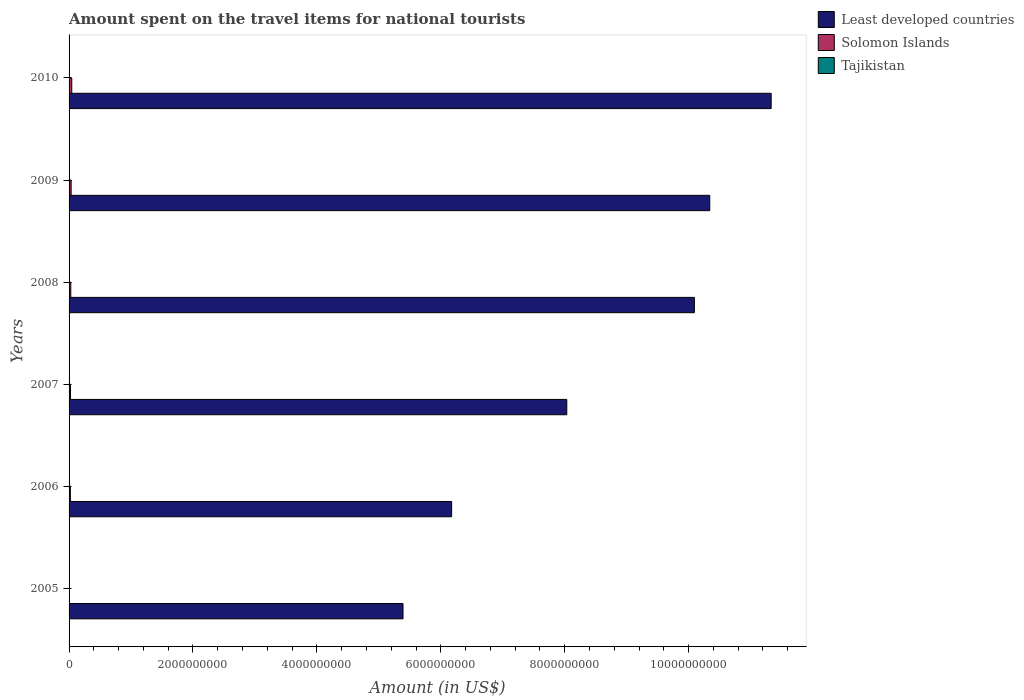How many groups of bars are there?
Ensure brevity in your answer.  6. Are the number of bars on each tick of the Y-axis equal?
Your response must be concise. Yes. What is the amount spent on the travel items for national tourists in Tajikistan in 2007?
Provide a succinct answer. 3.30e+06. Across all years, what is the maximum amount spent on the travel items for national tourists in Tajikistan?
Offer a very short reply. 4.50e+06. Across all years, what is the minimum amount spent on the travel items for national tourists in Least developed countries?
Your answer should be very brief. 5.39e+09. What is the total amount spent on the travel items for national tourists in Tajikistan in the graph?
Your answer should be compact. 1.81e+07. What is the difference between the amount spent on the travel items for national tourists in Least developed countries in 2006 and that in 2010?
Provide a succinct answer. -5.16e+09. What is the difference between the amount spent on the travel items for national tourists in Least developed countries in 2006 and the amount spent on the travel items for national tourists in Solomon Islands in 2005?
Provide a succinct answer. 6.17e+09. What is the average amount spent on the travel items for national tourists in Solomon Islands per year?
Make the answer very short. 2.50e+07. In the year 2007, what is the difference between the amount spent on the travel items for national tourists in Tajikistan and amount spent on the travel items for national tourists in Solomon Islands?
Provide a short and direct response. -1.93e+07. In how many years, is the amount spent on the travel items for national tourists in Least developed countries greater than 8000000000 US$?
Your answer should be compact. 4. What is the ratio of the amount spent on the travel items for national tourists in Solomon Islands in 2007 to that in 2008?
Your response must be concise. 0.82. What is the difference between the highest and the lowest amount spent on the travel items for national tourists in Solomon Islands?
Provide a succinct answer. 4.19e+07. In how many years, is the amount spent on the travel items for national tourists in Tajikistan greater than the average amount spent on the travel items for national tourists in Tajikistan taken over all years?
Give a very brief answer. 3. Is the sum of the amount spent on the travel items for national tourists in Solomon Islands in 2008 and 2010 greater than the maximum amount spent on the travel items for national tourists in Least developed countries across all years?
Your answer should be very brief. No. What does the 3rd bar from the top in 2009 represents?
Your response must be concise. Least developed countries. What does the 2nd bar from the bottom in 2008 represents?
Offer a terse response. Solomon Islands. Is it the case that in every year, the sum of the amount spent on the travel items for national tourists in Solomon Islands and amount spent on the travel items for national tourists in Least developed countries is greater than the amount spent on the travel items for national tourists in Tajikistan?
Your answer should be compact. Yes. How many bars are there?
Keep it short and to the point. 18. Are all the bars in the graph horizontal?
Offer a very short reply. Yes. Are the values on the major ticks of X-axis written in scientific E-notation?
Provide a succinct answer. No. Does the graph contain grids?
Your answer should be compact. No. Where does the legend appear in the graph?
Your answer should be very brief. Top right. How are the legend labels stacked?
Provide a succinct answer. Vertical. What is the title of the graph?
Keep it short and to the point. Amount spent on the travel items for national tourists. What is the label or title of the X-axis?
Keep it short and to the point. Amount (in US$). What is the label or title of the Y-axis?
Provide a short and direct response. Years. What is the Amount (in US$) in Least developed countries in 2005?
Make the answer very short. 5.39e+09. What is the Amount (in US$) of Solomon Islands in 2005?
Provide a short and direct response. 1.60e+06. What is the Amount (in US$) of Tajikistan in 2005?
Your answer should be very brief. 1.60e+06. What is the Amount (in US$) in Least developed countries in 2006?
Ensure brevity in your answer.  6.17e+09. What is the Amount (in US$) in Solomon Islands in 2006?
Make the answer very short. 2.11e+07. What is the Amount (in US$) of Tajikistan in 2006?
Provide a succinct answer. 2.10e+06. What is the Amount (in US$) of Least developed countries in 2007?
Make the answer very short. 8.03e+09. What is the Amount (in US$) of Solomon Islands in 2007?
Ensure brevity in your answer.  2.26e+07. What is the Amount (in US$) in Tajikistan in 2007?
Ensure brevity in your answer.  3.30e+06. What is the Amount (in US$) of Least developed countries in 2008?
Your answer should be very brief. 1.01e+1. What is the Amount (in US$) in Solomon Islands in 2008?
Offer a terse response. 2.75e+07. What is the Amount (in US$) in Tajikistan in 2008?
Keep it short and to the point. 4.20e+06. What is the Amount (in US$) of Least developed countries in 2009?
Give a very brief answer. 1.03e+1. What is the Amount (in US$) in Solomon Islands in 2009?
Provide a succinct answer. 3.34e+07. What is the Amount (in US$) of Tajikistan in 2009?
Your response must be concise. 2.40e+06. What is the Amount (in US$) in Least developed countries in 2010?
Your response must be concise. 1.13e+1. What is the Amount (in US$) of Solomon Islands in 2010?
Offer a terse response. 4.35e+07. What is the Amount (in US$) of Tajikistan in 2010?
Make the answer very short. 4.50e+06. Across all years, what is the maximum Amount (in US$) of Least developed countries?
Make the answer very short. 1.13e+1. Across all years, what is the maximum Amount (in US$) in Solomon Islands?
Give a very brief answer. 4.35e+07. Across all years, what is the maximum Amount (in US$) of Tajikistan?
Keep it short and to the point. 4.50e+06. Across all years, what is the minimum Amount (in US$) in Least developed countries?
Offer a terse response. 5.39e+09. Across all years, what is the minimum Amount (in US$) of Solomon Islands?
Offer a very short reply. 1.60e+06. Across all years, what is the minimum Amount (in US$) of Tajikistan?
Keep it short and to the point. 1.60e+06. What is the total Amount (in US$) in Least developed countries in the graph?
Your answer should be very brief. 5.14e+1. What is the total Amount (in US$) in Solomon Islands in the graph?
Ensure brevity in your answer.  1.50e+08. What is the total Amount (in US$) in Tajikistan in the graph?
Your answer should be very brief. 1.81e+07. What is the difference between the Amount (in US$) of Least developed countries in 2005 and that in 2006?
Offer a terse response. -7.85e+08. What is the difference between the Amount (in US$) of Solomon Islands in 2005 and that in 2006?
Offer a terse response. -1.95e+07. What is the difference between the Amount (in US$) of Tajikistan in 2005 and that in 2006?
Your answer should be compact. -5.00e+05. What is the difference between the Amount (in US$) of Least developed countries in 2005 and that in 2007?
Offer a terse response. -2.64e+09. What is the difference between the Amount (in US$) of Solomon Islands in 2005 and that in 2007?
Offer a very short reply. -2.10e+07. What is the difference between the Amount (in US$) of Tajikistan in 2005 and that in 2007?
Your answer should be very brief. -1.70e+06. What is the difference between the Amount (in US$) of Least developed countries in 2005 and that in 2008?
Your answer should be compact. -4.70e+09. What is the difference between the Amount (in US$) in Solomon Islands in 2005 and that in 2008?
Provide a short and direct response. -2.59e+07. What is the difference between the Amount (in US$) in Tajikistan in 2005 and that in 2008?
Ensure brevity in your answer.  -2.60e+06. What is the difference between the Amount (in US$) in Least developed countries in 2005 and that in 2009?
Offer a very short reply. -4.95e+09. What is the difference between the Amount (in US$) of Solomon Islands in 2005 and that in 2009?
Offer a very short reply. -3.18e+07. What is the difference between the Amount (in US$) of Tajikistan in 2005 and that in 2009?
Offer a very short reply. -8.00e+05. What is the difference between the Amount (in US$) in Least developed countries in 2005 and that in 2010?
Your answer should be very brief. -5.94e+09. What is the difference between the Amount (in US$) of Solomon Islands in 2005 and that in 2010?
Provide a short and direct response. -4.19e+07. What is the difference between the Amount (in US$) of Tajikistan in 2005 and that in 2010?
Give a very brief answer. -2.90e+06. What is the difference between the Amount (in US$) of Least developed countries in 2006 and that in 2007?
Your answer should be compact. -1.86e+09. What is the difference between the Amount (in US$) of Solomon Islands in 2006 and that in 2007?
Offer a terse response. -1.50e+06. What is the difference between the Amount (in US$) of Tajikistan in 2006 and that in 2007?
Ensure brevity in your answer.  -1.20e+06. What is the difference between the Amount (in US$) in Least developed countries in 2006 and that in 2008?
Offer a very short reply. -3.92e+09. What is the difference between the Amount (in US$) in Solomon Islands in 2006 and that in 2008?
Your answer should be compact. -6.40e+06. What is the difference between the Amount (in US$) in Tajikistan in 2006 and that in 2008?
Make the answer very short. -2.10e+06. What is the difference between the Amount (in US$) in Least developed countries in 2006 and that in 2009?
Your answer should be compact. -4.17e+09. What is the difference between the Amount (in US$) in Solomon Islands in 2006 and that in 2009?
Your answer should be compact. -1.23e+07. What is the difference between the Amount (in US$) in Tajikistan in 2006 and that in 2009?
Your answer should be very brief. -3.00e+05. What is the difference between the Amount (in US$) of Least developed countries in 2006 and that in 2010?
Make the answer very short. -5.16e+09. What is the difference between the Amount (in US$) of Solomon Islands in 2006 and that in 2010?
Offer a very short reply. -2.24e+07. What is the difference between the Amount (in US$) in Tajikistan in 2006 and that in 2010?
Offer a terse response. -2.40e+06. What is the difference between the Amount (in US$) in Least developed countries in 2007 and that in 2008?
Your response must be concise. -2.06e+09. What is the difference between the Amount (in US$) in Solomon Islands in 2007 and that in 2008?
Your answer should be compact. -4.90e+06. What is the difference between the Amount (in US$) of Tajikistan in 2007 and that in 2008?
Provide a short and direct response. -9.00e+05. What is the difference between the Amount (in US$) of Least developed countries in 2007 and that in 2009?
Offer a terse response. -2.31e+09. What is the difference between the Amount (in US$) of Solomon Islands in 2007 and that in 2009?
Your response must be concise. -1.08e+07. What is the difference between the Amount (in US$) of Least developed countries in 2007 and that in 2010?
Ensure brevity in your answer.  -3.30e+09. What is the difference between the Amount (in US$) of Solomon Islands in 2007 and that in 2010?
Keep it short and to the point. -2.09e+07. What is the difference between the Amount (in US$) in Tajikistan in 2007 and that in 2010?
Your answer should be compact. -1.20e+06. What is the difference between the Amount (in US$) in Least developed countries in 2008 and that in 2009?
Your answer should be compact. -2.48e+08. What is the difference between the Amount (in US$) of Solomon Islands in 2008 and that in 2009?
Offer a terse response. -5.90e+06. What is the difference between the Amount (in US$) in Tajikistan in 2008 and that in 2009?
Provide a succinct answer. 1.80e+06. What is the difference between the Amount (in US$) in Least developed countries in 2008 and that in 2010?
Ensure brevity in your answer.  -1.24e+09. What is the difference between the Amount (in US$) of Solomon Islands in 2008 and that in 2010?
Ensure brevity in your answer.  -1.60e+07. What is the difference between the Amount (in US$) in Least developed countries in 2009 and that in 2010?
Ensure brevity in your answer.  -9.91e+08. What is the difference between the Amount (in US$) in Solomon Islands in 2009 and that in 2010?
Your answer should be very brief. -1.01e+07. What is the difference between the Amount (in US$) in Tajikistan in 2009 and that in 2010?
Keep it short and to the point. -2.10e+06. What is the difference between the Amount (in US$) of Least developed countries in 2005 and the Amount (in US$) of Solomon Islands in 2006?
Your response must be concise. 5.37e+09. What is the difference between the Amount (in US$) in Least developed countries in 2005 and the Amount (in US$) in Tajikistan in 2006?
Your answer should be very brief. 5.39e+09. What is the difference between the Amount (in US$) in Solomon Islands in 2005 and the Amount (in US$) in Tajikistan in 2006?
Provide a succinct answer. -5.00e+05. What is the difference between the Amount (in US$) in Least developed countries in 2005 and the Amount (in US$) in Solomon Islands in 2007?
Offer a very short reply. 5.37e+09. What is the difference between the Amount (in US$) in Least developed countries in 2005 and the Amount (in US$) in Tajikistan in 2007?
Ensure brevity in your answer.  5.39e+09. What is the difference between the Amount (in US$) of Solomon Islands in 2005 and the Amount (in US$) of Tajikistan in 2007?
Offer a very short reply. -1.70e+06. What is the difference between the Amount (in US$) of Least developed countries in 2005 and the Amount (in US$) of Solomon Islands in 2008?
Provide a short and direct response. 5.36e+09. What is the difference between the Amount (in US$) of Least developed countries in 2005 and the Amount (in US$) of Tajikistan in 2008?
Give a very brief answer. 5.39e+09. What is the difference between the Amount (in US$) of Solomon Islands in 2005 and the Amount (in US$) of Tajikistan in 2008?
Give a very brief answer. -2.60e+06. What is the difference between the Amount (in US$) of Least developed countries in 2005 and the Amount (in US$) of Solomon Islands in 2009?
Give a very brief answer. 5.36e+09. What is the difference between the Amount (in US$) in Least developed countries in 2005 and the Amount (in US$) in Tajikistan in 2009?
Your answer should be compact. 5.39e+09. What is the difference between the Amount (in US$) in Solomon Islands in 2005 and the Amount (in US$) in Tajikistan in 2009?
Make the answer very short. -8.00e+05. What is the difference between the Amount (in US$) in Least developed countries in 2005 and the Amount (in US$) in Solomon Islands in 2010?
Make the answer very short. 5.35e+09. What is the difference between the Amount (in US$) in Least developed countries in 2005 and the Amount (in US$) in Tajikistan in 2010?
Your answer should be very brief. 5.39e+09. What is the difference between the Amount (in US$) of Solomon Islands in 2005 and the Amount (in US$) of Tajikistan in 2010?
Provide a short and direct response. -2.90e+06. What is the difference between the Amount (in US$) in Least developed countries in 2006 and the Amount (in US$) in Solomon Islands in 2007?
Your answer should be very brief. 6.15e+09. What is the difference between the Amount (in US$) of Least developed countries in 2006 and the Amount (in US$) of Tajikistan in 2007?
Provide a short and direct response. 6.17e+09. What is the difference between the Amount (in US$) in Solomon Islands in 2006 and the Amount (in US$) in Tajikistan in 2007?
Provide a short and direct response. 1.78e+07. What is the difference between the Amount (in US$) in Least developed countries in 2006 and the Amount (in US$) in Solomon Islands in 2008?
Give a very brief answer. 6.15e+09. What is the difference between the Amount (in US$) in Least developed countries in 2006 and the Amount (in US$) in Tajikistan in 2008?
Offer a very short reply. 6.17e+09. What is the difference between the Amount (in US$) of Solomon Islands in 2006 and the Amount (in US$) of Tajikistan in 2008?
Ensure brevity in your answer.  1.69e+07. What is the difference between the Amount (in US$) of Least developed countries in 2006 and the Amount (in US$) of Solomon Islands in 2009?
Ensure brevity in your answer.  6.14e+09. What is the difference between the Amount (in US$) in Least developed countries in 2006 and the Amount (in US$) in Tajikistan in 2009?
Your answer should be compact. 6.17e+09. What is the difference between the Amount (in US$) in Solomon Islands in 2006 and the Amount (in US$) in Tajikistan in 2009?
Make the answer very short. 1.87e+07. What is the difference between the Amount (in US$) of Least developed countries in 2006 and the Amount (in US$) of Solomon Islands in 2010?
Give a very brief answer. 6.13e+09. What is the difference between the Amount (in US$) in Least developed countries in 2006 and the Amount (in US$) in Tajikistan in 2010?
Your answer should be compact. 6.17e+09. What is the difference between the Amount (in US$) in Solomon Islands in 2006 and the Amount (in US$) in Tajikistan in 2010?
Give a very brief answer. 1.66e+07. What is the difference between the Amount (in US$) of Least developed countries in 2007 and the Amount (in US$) of Solomon Islands in 2008?
Your response must be concise. 8.01e+09. What is the difference between the Amount (in US$) in Least developed countries in 2007 and the Amount (in US$) in Tajikistan in 2008?
Make the answer very short. 8.03e+09. What is the difference between the Amount (in US$) in Solomon Islands in 2007 and the Amount (in US$) in Tajikistan in 2008?
Your response must be concise. 1.84e+07. What is the difference between the Amount (in US$) of Least developed countries in 2007 and the Amount (in US$) of Solomon Islands in 2009?
Provide a succinct answer. 8.00e+09. What is the difference between the Amount (in US$) in Least developed countries in 2007 and the Amount (in US$) in Tajikistan in 2009?
Offer a terse response. 8.03e+09. What is the difference between the Amount (in US$) in Solomon Islands in 2007 and the Amount (in US$) in Tajikistan in 2009?
Offer a terse response. 2.02e+07. What is the difference between the Amount (in US$) of Least developed countries in 2007 and the Amount (in US$) of Solomon Islands in 2010?
Ensure brevity in your answer.  7.99e+09. What is the difference between the Amount (in US$) in Least developed countries in 2007 and the Amount (in US$) in Tajikistan in 2010?
Make the answer very short. 8.03e+09. What is the difference between the Amount (in US$) in Solomon Islands in 2007 and the Amount (in US$) in Tajikistan in 2010?
Give a very brief answer. 1.81e+07. What is the difference between the Amount (in US$) in Least developed countries in 2008 and the Amount (in US$) in Solomon Islands in 2009?
Keep it short and to the point. 1.01e+1. What is the difference between the Amount (in US$) of Least developed countries in 2008 and the Amount (in US$) of Tajikistan in 2009?
Give a very brief answer. 1.01e+1. What is the difference between the Amount (in US$) of Solomon Islands in 2008 and the Amount (in US$) of Tajikistan in 2009?
Give a very brief answer. 2.51e+07. What is the difference between the Amount (in US$) in Least developed countries in 2008 and the Amount (in US$) in Solomon Islands in 2010?
Offer a very short reply. 1.00e+1. What is the difference between the Amount (in US$) in Least developed countries in 2008 and the Amount (in US$) in Tajikistan in 2010?
Your answer should be compact. 1.01e+1. What is the difference between the Amount (in US$) in Solomon Islands in 2008 and the Amount (in US$) in Tajikistan in 2010?
Provide a short and direct response. 2.30e+07. What is the difference between the Amount (in US$) of Least developed countries in 2009 and the Amount (in US$) of Solomon Islands in 2010?
Ensure brevity in your answer.  1.03e+1. What is the difference between the Amount (in US$) in Least developed countries in 2009 and the Amount (in US$) in Tajikistan in 2010?
Your answer should be very brief. 1.03e+1. What is the difference between the Amount (in US$) in Solomon Islands in 2009 and the Amount (in US$) in Tajikistan in 2010?
Your response must be concise. 2.89e+07. What is the average Amount (in US$) of Least developed countries per year?
Offer a terse response. 8.56e+09. What is the average Amount (in US$) of Solomon Islands per year?
Your response must be concise. 2.50e+07. What is the average Amount (in US$) of Tajikistan per year?
Ensure brevity in your answer.  3.02e+06. In the year 2005, what is the difference between the Amount (in US$) of Least developed countries and Amount (in US$) of Solomon Islands?
Give a very brief answer. 5.39e+09. In the year 2005, what is the difference between the Amount (in US$) in Least developed countries and Amount (in US$) in Tajikistan?
Make the answer very short. 5.39e+09. In the year 2005, what is the difference between the Amount (in US$) in Solomon Islands and Amount (in US$) in Tajikistan?
Provide a succinct answer. 0. In the year 2006, what is the difference between the Amount (in US$) of Least developed countries and Amount (in US$) of Solomon Islands?
Give a very brief answer. 6.15e+09. In the year 2006, what is the difference between the Amount (in US$) of Least developed countries and Amount (in US$) of Tajikistan?
Offer a terse response. 6.17e+09. In the year 2006, what is the difference between the Amount (in US$) in Solomon Islands and Amount (in US$) in Tajikistan?
Offer a terse response. 1.90e+07. In the year 2007, what is the difference between the Amount (in US$) in Least developed countries and Amount (in US$) in Solomon Islands?
Give a very brief answer. 8.01e+09. In the year 2007, what is the difference between the Amount (in US$) of Least developed countries and Amount (in US$) of Tajikistan?
Provide a short and direct response. 8.03e+09. In the year 2007, what is the difference between the Amount (in US$) in Solomon Islands and Amount (in US$) in Tajikistan?
Make the answer very short. 1.93e+07. In the year 2008, what is the difference between the Amount (in US$) in Least developed countries and Amount (in US$) in Solomon Islands?
Give a very brief answer. 1.01e+1. In the year 2008, what is the difference between the Amount (in US$) of Least developed countries and Amount (in US$) of Tajikistan?
Your response must be concise. 1.01e+1. In the year 2008, what is the difference between the Amount (in US$) in Solomon Islands and Amount (in US$) in Tajikistan?
Offer a terse response. 2.33e+07. In the year 2009, what is the difference between the Amount (in US$) of Least developed countries and Amount (in US$) of Solomon Islands?
Your response must be concise. 1.03e+1. In the year 2009, what is the difference between the Amount (in US$) in Least developed countries and Amount (in US$) in Tajikistan?
Your answer should be compact. 1.03e+1. In the year 2009, what is the difference between the Amount (in US$) of Solomon Islands and Amount (in US$) of Tajikistan?
Keep it short and to the point. 3.10e+07. In the year 2010, what is the difference between the Amount (in US$) of Least developed countries and Amount (in US$) of Solomon Islands?
Give a very brief answer. 1.13e+1. In the year 2010, what is the difference between the Amount (in US$) in Least developed countries and Amount (in US$) in Tajikistan?
Your response must be concise. 1.13e+1. In the year 2010, what is the difference between the Amount (in US$) in Solomon Islands and Amount (in US$) in Tajikistan?
Give a very brief answer. 3.90e+07. What is the ratio of the Amount (in US$) of Least developed countries in 2005 to that in 2006?
Offer a very short reply. 0.87. What is the ratio of the Amount (in US$) in Solomon Islands in 2005 to that in 2006?
Keep it short and to the point. 0.08. What is the ratio of the Amount (in US$) of Tajikistan in 2005 to that in 2006?
Give a very brief answer. 0.76. What is the ratio of the Amount (in US$) of Least developed countries in 2005 to that in 2007?
Give a very brief answer. 0.67. What is the ratio of the Amount (in US$) of Solomon Islands in 2005 to that in 2007?
Make the answer very short. 0.07. What is the ratio of the Amount (in US$) in Tajikistan in 2005 to that in 2007?
Your answer should be compact. 0.48. What is the ratio of the Amount (in US$) in Least developed countries in 2005 to that in 2008?
Provide a short and direct response. 0.53. What is the ratio of the Amount (in US$) of Solomon Islands in 2005 to that in 2008?
Ensure brevity in your answer.  0.06. What is the ratio of the Amount (in US$) in Tajikistan in 2005 to that in 2008?
Your answer should be very brief. 0.38. What is the ratio of the Amount (in US$) in Least developed countries in 2005 to that in 2009?
Keep it short and to the point. 0.52. What is the ratio of the Amount (in US$) of Solomon Islands in 2005 to that in 2009?
Make the answer very short. 0.05. What is the ratio of the Amount (in US$) of Least developed countries in 2005 to that in 2010?
Provide a short and direct response. 0.48. What is the ratio of the Amount (in US$) of Solomon Islands in 2005 to that in 2010?
Your answer should be very brief. 0.04. What is the ratio of the Amount (in US$) in Tajikistan in 2005 to that in 2010?
Make the answer very short. 0.36. What is the ratio of the Amount (in US$) in Least developed countries in 2006 to that in 2007?
Your response must be concise. 0.77. What is the ratio of the Amount (in US$) of Solomon Islands in 2006 to that in 2007?
Provide a short and direct response. 0.93. What is the ratio of the Amount (in US$) in Tajikistan in 2006 to that in 2007?
Offer a terse response. 0.64. What is the ratio of the Amount (in US$) of Least developed countries in 2006 to that in 2008?
Ensure brevity in your answer.  0.61. What is the ratio of the Amount (in US$) of Solomon Islands in 2006 to that in 2008?
Your answer should be very brief. 0.77. What is the ratio of the Amount (in US$) in Least developed countries in 2006 to that in 2009?
Give a very brief answer. 0.6. What is the ratio of the Amount (in US$) in Solomon Islands in 2006 to that in 2009?
Your answer should be compact. 0.63. What is the ratio of the Amount (in US$) in Tajikistan in 2006 to that in 2009?
Make the answer very short. 0.88. What is the ratio of the Amount (in US$) in Least developed countries in 2006 to that in 2010?
Provide a short and direct response. 0.54. What is the ratio of the Amount (in US$) of Solomon Islands in 2006 to that in 2010?
Offer a very short reply. 0.49. What is the ratio of the Amount (in US$) in Tajikistan in 2006 to that in 2010?
Make the answer very short. 0.47. What is the ratio of the Amount (in US$) of Least developed countries in 2007 to that in 2008?
Your response must be concise. 0.8. What is the ratio of the Amount (in US$) in Solomon Islands in 2007 to that in 2008?
Make the answer very short. 0.82. What is the ratio of the Amount (in US$) in Tajikistan in 2007 to that in 2008?
Give a very brief answer. 0.79. What is the ratio of the Amount (in US$) in Least developed countries in 2007 to that in 2009?
Make the answer very short. 0.78. What is the ratio of the Amount (in US$) in Solomon Islands in 2007 to that in 2009?
Give a very brief answer. 0.68. What is the ratio of the Amount (in US$) of Tajikistan in 2007 to that in 2009?
Your answer should be compact. 1.38. What is the ratio of the Amount (in US$) in Least developed countries in 2007 to that in 2010?
Your answer should be compact. 0.71. What is the ratio of the Amount (in US$) of Solomon Islands in 2007 to that in 2010?
Your response must be concise. 0.52. What is the ratio of the Amount (in US$) in Tajikistan in 2007 to that in 2010?
Provide a short and direct response. 0.73. What is the ratio of the Amount (in US$) in Solomon Islands in 2008 to that in 2009?
Keep it short and to the point. 0.82. What is the ratio of the Amount (in US$) in Tajikistan in 2008 to that in 2009?
Make the answer very short. 1.75. What is the ratio of the Amount (in US$) of Least developed countries in 2008 to that in 2010?
Give a very brief answer. 0.89. What is the ratio of the Amount (in US$) of Solomon Islands in 2008 to that in 2010?
Your answer should be very brief. 0.63. What is the ratio of the Amount (in US$) of Least developed countries in 2009 to that in 2010?
Provide a short and direct response. 0.91. What is the ratio of the Amount (in US$) in Solomon Islands in 2009 to that in 2010?
Give a very brief answer. 0.77. What is the ratio of the Amount (in US$) of Tajikistan in 2009 to that in 2010?
Provide a short and direct response. 0.53. What is the difference between the highest and the second highest Amount (in US$) of Least developed countries?
Your answer should be compact. 9.91e+08. What is the difference between the highest and the second highest Amount (in US$) of Solomon Islands?
Your answer should be compact. 1.01e+07. What is the difference between the highest and the lowest Amount (in US$) of Least developed countries?
Ensure brevity in your answer.  5.94e+09. What is the difference between the highest and the lowest Amount (in US$) of Solomon Islands?
Your answer should be compact. 4.19e+07. What is the difference between the highest and the lowest Amount (in US$) of Tajikistan?
Your answer should be very brief. 2.90e+06. 